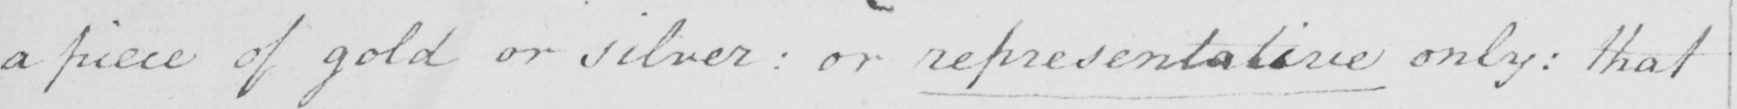What is written in this line of handwriting? a piece of gold or silver  :  or representative only :  that 